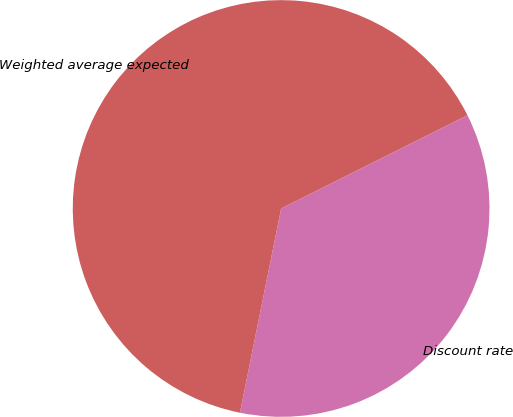Convert chart to OTSL. <chart><loc_0><loc_0><loc_500><loc_500><pie_chart><fcel>Discount rate<fcel>Weighted average expected<nl><fcel>35.56%<fcel>64.44%<nl></chart> 